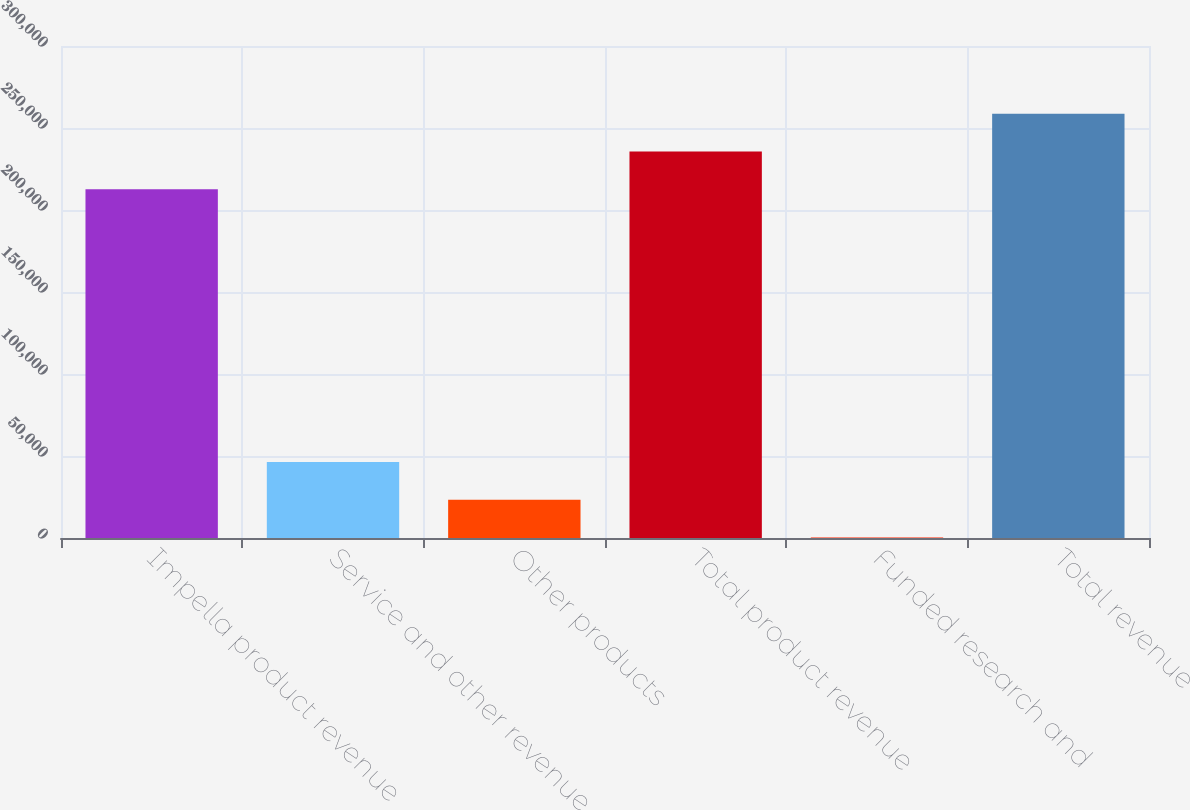Convert chart. <chart><loc_0><loc_0><loc_500><loc_500><bar_chart><fcel>Impella product revenue<fcel>Service and other revenue<fcel>Other products<fcel>Total product revenue<fcel>Funded research and<fcel>Total revenue<nl><fcel>212665<fcel>46351<fcel>23356<fcel>235660<fcel>361<fcel>258655<nl></chart> 